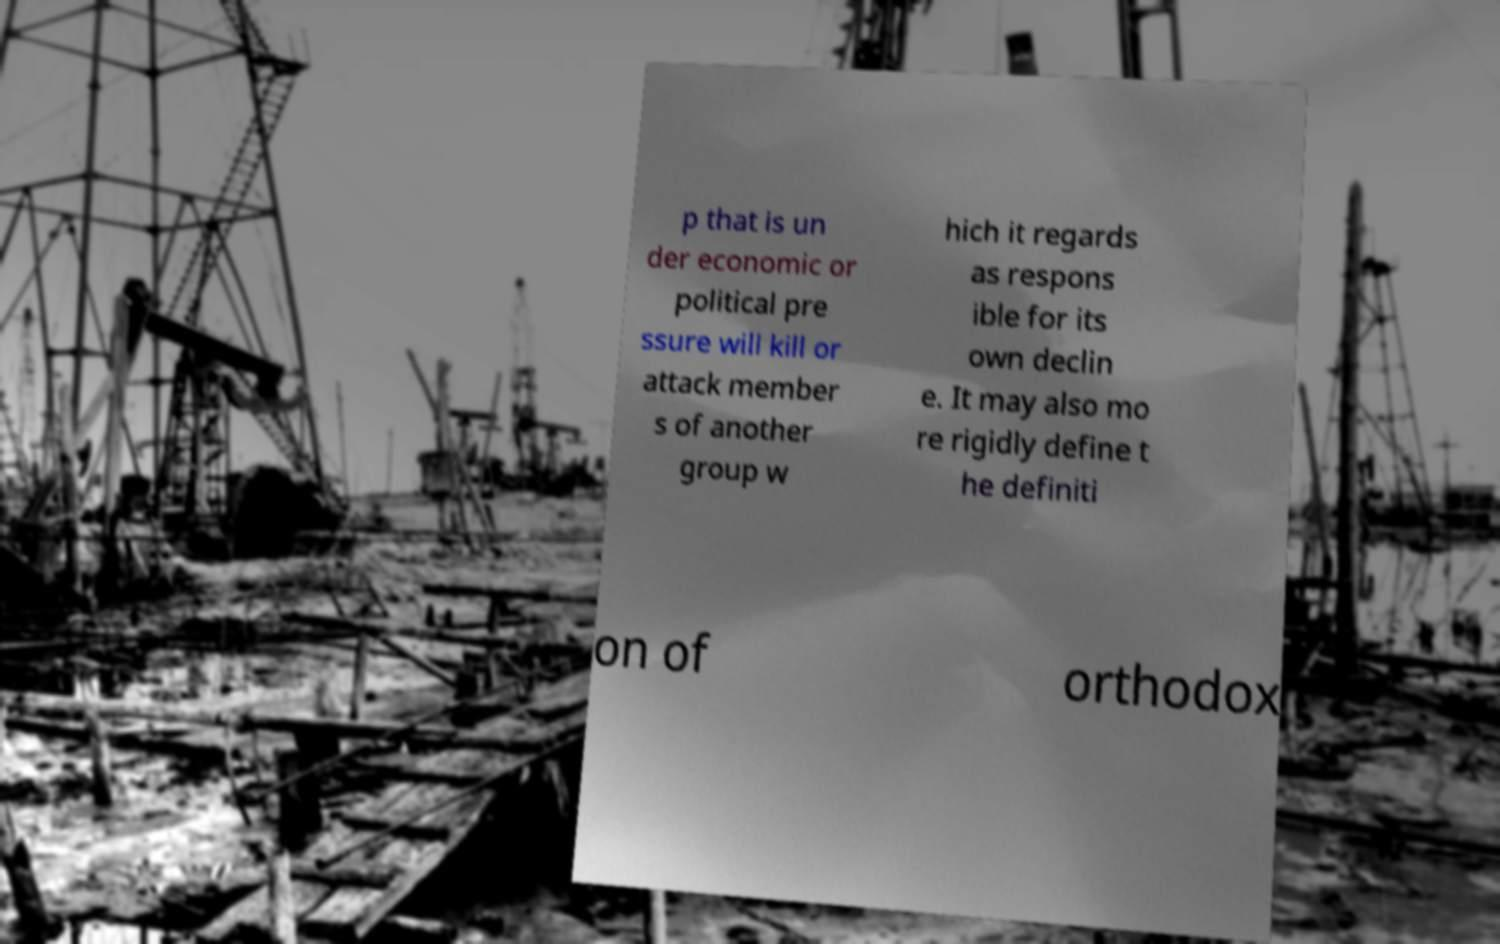Can you read and provide the text displayed in the image?This photo seems to have some interesting text. Can you extract and type it out for me? p that is un der economic or political pre ssure will kill or attack member s of another group w hich it regards as respons ible for its own declin e. It may also mo re rigidly define t he definiti on of orthodox 